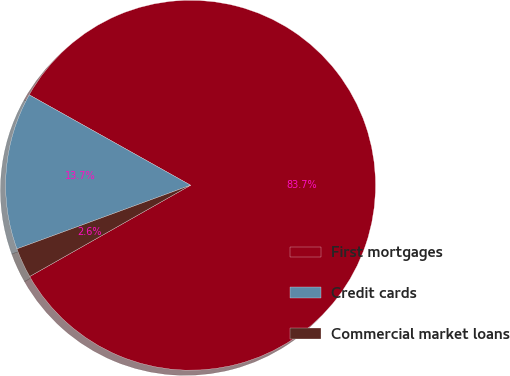Convert chart to OTSL. <chart><loc_0><loc_0><loc_500><loc_500><pie_chart><fcel>First mortgages<fcel>Credit cards<fcel>Commercial market loans<nl><fcel>83.66%<fcel>13.72%<fcel>2.62%<nl></chart> 